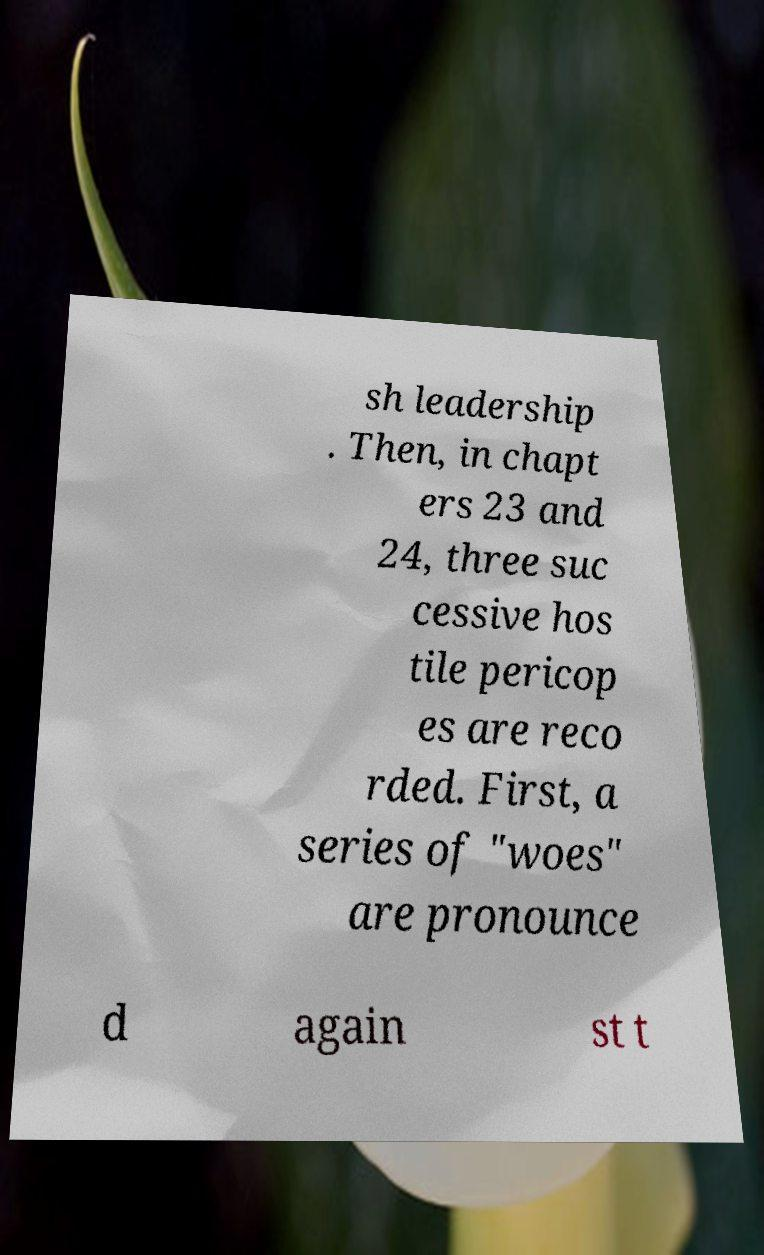There's text embedded in this image that I need extracted. Can you transcribe it verbatim? sh leadership . Then, in chapt ers 23 and 24, three suc cessive hos tile pericop es are reco rded. First, a series of "woes" are pronounce d again st t 